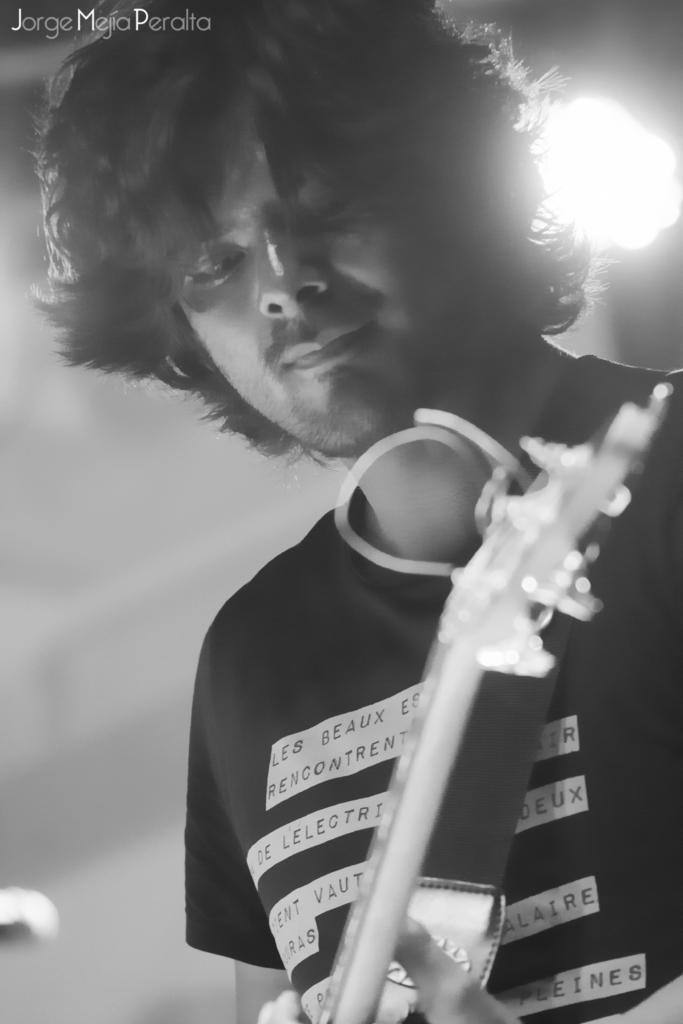What is the main subject of the image? There is a person in the image. What is the person doing in the image? The person is holding a musical instrument. Can you describe the background of the image? The background of the image is blurred. Is there any additional information or markings in the image? Yes, there is a watermark in the top left corner of the image. How many cows can be seen in the image? There are no cows present in the image. What type of insect is flying around the person in the image? There is no insect visible in the image. 